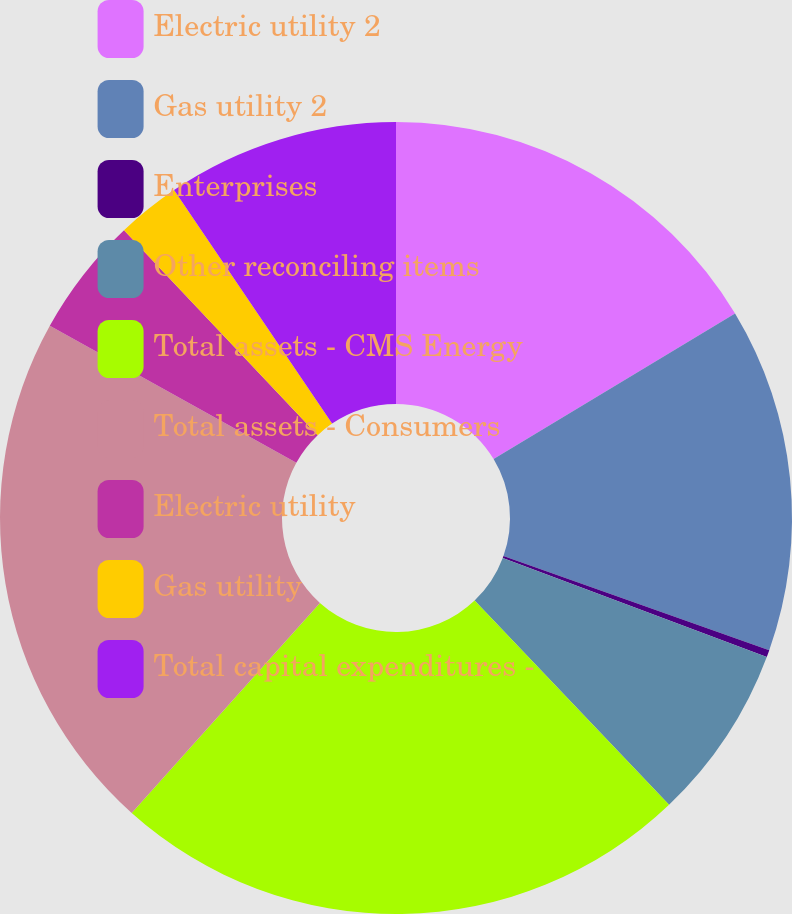Convert chart to OTSL. <chart><loc_0><loc_0><loc_500><loc_500><pie_chart><fcel>Electric utility 2<fcel>Gas utility 2<fcel>Enterprises<fcel>Other reconciling items<fcel>Total assets - CMS Energy<fcel>Total assets - Consumers<fcel>Electric utility<fcel>Gas utility<fcel>Total capital expenditures -<nl><fcel>16.36%<fcel>14.06%<fcel>0.29%<fcel>7.18%<fcel>23.74%<fcel>21.44%<fcel>4.88%<fcel>2.58%<fcel>9.47%<nl></chart> 